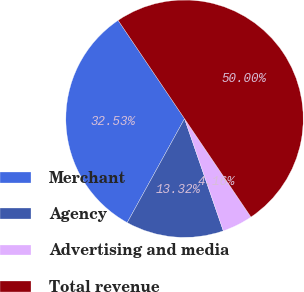Convert chart. <chart><loc_0><loc_0><loc_500><loc_500><pie_chart><fcel>Merchant<fcel>Agency<fcel>Advertising and media<fcel>Total revenue<nl><fcel>32.53%<fcel>13.32%<fcel>4.16%<fcel>50.0%<nl></chart> 